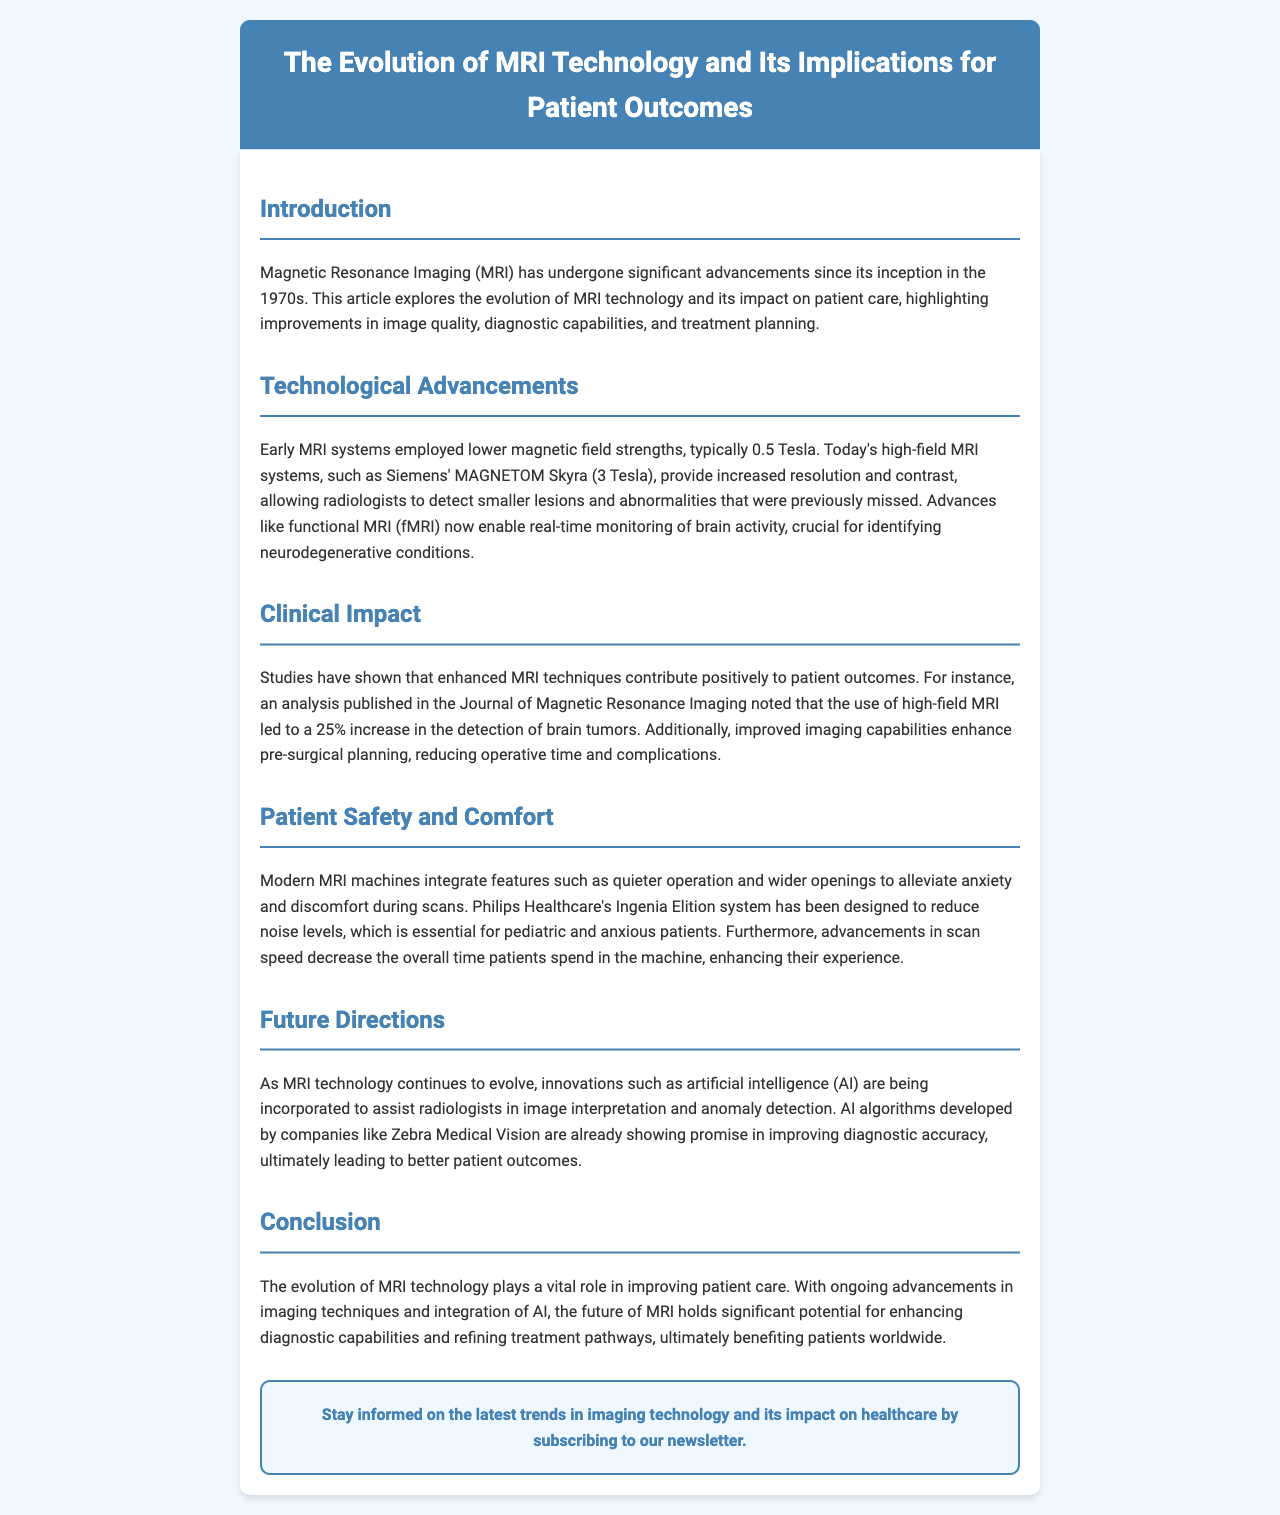What decade did MRI technology begin? The document states that Magnetic Resonance Imaging (MRI) has undergone significant advancements since its inception in the 1970s.
Answer: 1970s What is the magnetic field strength of Siemens' MAGNETOM Skyra? The document mentions that today’s high-field MRI systems, such as Siemens' MAGNETOM Skyra, provide 3 Tesla.
Answer: 3 Tesla By what percentage has high-field MRI increased brain tumor detection? An analysis noted in the document states that high-field MRI led to a 25% increase in the detection of brain tumors.
Answer: 25% Which system is designed to reduce noise levels during MRI scans? The document refers to Philips Healthcare's Ingenia Elition system as being designed to reduce noise levels in MRI scans.
Answer: Ingenia Elition What technology is being incorporated into MRI to assist radiologists? The document mentions the integration of artificial intelligence (AI) into MRI technology to assist radiologists.
Answer: artificial intelligence How have modern MRI machines improved patient comfort? The document explains that modern MRI machines integrate features such as quieter operation and wider openings to improve patient comfort.
Answer: quieter operation and wider openings What advancements have contributed to reduced operative time in surgeries? Enhanced MRI techniques have been noted in the document to contribute positively to pre-surgical planning, thereby reducing operative time.
Answer: Enhanced MRI techniques What future potential does the document suggest for MRI technology? The document suggests that ongoing advancements in imaging techniques and integration of AI hold significant potential for enhancing diagnostic capabilities.
Answer: enhancing diagnostic capabilities 